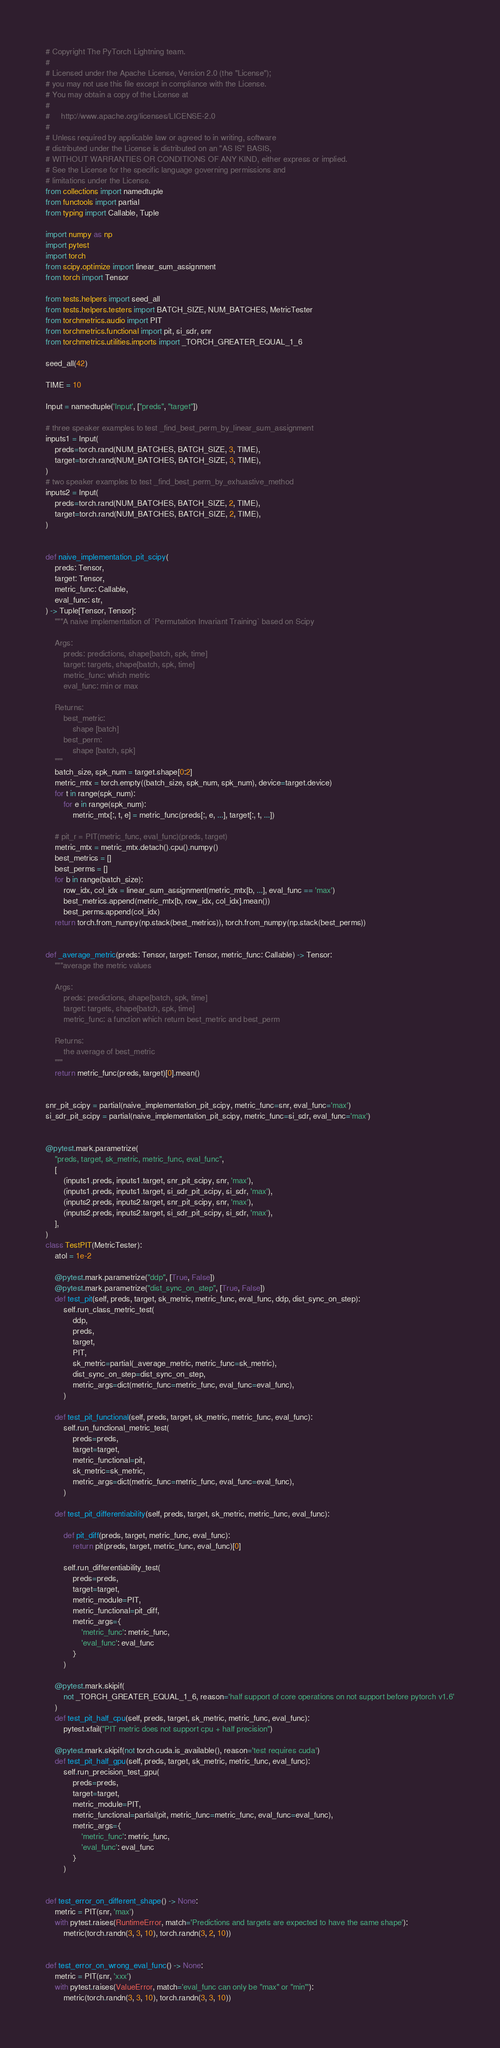<code> <loc_0><loc_0><loc_500><loc_500><_Python_># Copyright The PyTorch Lightning team.
#
# Licensed under the Apache License, Version 2.0 (the "License");
# you may not use this file except in compliance with the License.
# You may obtain a copy of the License at
#
#     http://www.apache.org/licenses/LICENSE-2.0
#
# Unless required by applicable law or agreed to in writing, software
# distributed under the License is distributed on an "AS IS" BASIS,
# WITHOUT WARRANTIES OR CONDITIONS OF ANY KIND, either express or implied.
# See the License for the specific language governing permissions and
# limitations under the License.
from collections import namedtuple
from functools import partial
from typing import Callable, Tuple

import numpy as np
import pytest
import torch
from scipy.optimize import linear_sum_assignment
from torch import Tensor

from tests.helpers import seed_all
from tests.helpers.testers import BATCH_SIZE, NUM_BATCHES, MetricTester
from torchmetrics.audio import PIT
from torchmetrics.functional import pit, si_sdr, snr
from torchmetrics.utilities.imports import _TORCH_GREATER_EQUAL_1_6

seed_all(42)

TIME = 10

Input = namedtuple('Input', ["preds", "target"])

# three speaker examples to test _find_best_perm_by_linear_sum_assignment
inputs1 = Input(
    preds=torch.rand(NUM_BATCHES, BATCH_SIZE, 3, TIME),
    target=torch.rand(NUM_BATCHES, BATCH_SIZE, 3, TIME),
)
# two speaker examples to test _find_best_perm_by_exhuastive_method
inputs2 = Input(
    preds=torch.rand(NUM_BATCHES, BATCH_SIZE, 2, TIME),
    target=torch.rand(NUM_BATCHES, BATCH_SIZE, 2, TIME),
)


def naive_implementation_pit_scipy(
    preds: Tensor,
    target: Tensor,
    metric_func: Callable,
    eval_func: str,
) -> Tuple[Tensor, Tensor]:
    """A naive implementation of `Permutation Invariant Training` based on Scipy

    Args:
        preds: predictions, shape[batch, spk, time]
        target: targets, shape[batch, spk, time]
        metric_func: which metric
        eval_func: min or max

    Returns:
        best_metric:
            shape [batch]
        best_perm:
            shape [batch, spk]
    """
    batch_size, spk_num = target.shape[0:2]
    metric_mtx = torch.empty((batch_size, spk_num, spk_num), device=target.device)
    for t in range(spk_num):
        for e in range(spk_num):
            metric_mtx[:, t, e] = metric_func(preds[:, e, ...], target[:, t, ...])

    # pit_r = PIT(metric_func, eval_func)(preds, target)
    metric_mtx = metric_mtx.detach().cpu().numpy()
    best_metrics = []
    best_perms = []
    for b in range(batch_size):
        row_idx, col_idx = linear_sum_assignment(metric_mtx[b, ...], eval_func == 'max')
        best_metrics.append(metric_mtx[b, row_idx, col_idx].mean())
        best_perms.append(col_idx)
    return torch.from_numpy(np.stack(best_metrics)), torch.from_numpy(np.stack(best_perms))


def _average_metric(preds: Tensor, target: Tensor, metric_func: Callable) -> Tensor:
    """average the metric values

    Args:
        preds: predictions, shape[batch, spk, time]
        target: targets, shape[batch, spk, time]
        metric_func: a function which return best_metric and best_perm

    Returns:
        the average of best_metric
    """
    return metric_func(preds, target)[0].mean()


snr_pit_scipy = partial(naive_implementation_pit_scipy, metric_func=snr, eval_func='max')
si_sdr_pit_scipy = partial(naive_implementation_pit_scipy, metric_func=si_sdr, eval_func='max')


@pytest.mark.parametrize(
    "preds, target, sk_metric, metric_func, eval_func",
    [
        (inputs1.preds, inputs1.target, snr_pit_scipy, snr, 'max'),
        (inputs1.preds, inputs1.target, si_sdr_pit_scipy, si_sdr, 'max'),
        (inputs2.preds, inputs2.target, snr_pit_scipy, snr, 'max'),
        (inputs2.preds, inputs2.target, si_sdr_pit_scipy, si_sdr, 'max'),
    ],
)
class TestPIT(MetricTester):
    atol = 1e-2

    @pytest.mark.parametrize("ddp", [True, False])
    @pytest.mark.parametrize("dist_sync_on_step", [True, False])
    def test_pit(self, preds, target, sk_metric, metric_func, eval_func, ddp, dist_sync_on_step):
        self.run_class_metric_test(
            ddp,
            preds,
            target,
            PIT,
            sk_metric=partial(_average_metric, metric_func=sk_metric),
            dist_sync_on_step=dist_sync_on_step,
            metric_args=dict(metric_func=metric_func, eval_func=eval_func),
        )

    def test_pit_functional(self, preds, target, sk_metric, metric_func, eval_func):
        self.run_functional_metric_test(
            preds=preds,
            target=target,
            metric_functional=pit,
            sk_metric=sk_metric,
            metric_args=dict(metric_func=metric_func, eval_func=eval_func),
        )

    def test_pit_differentiability(self, preds, target, sk_metric, metric_func, eval_func):

        def pit_diff(preds, target, metric_func, eval_func):
            return pit(preds, target, metric_func, eval_func)[0]

        self.run_differentiability_test(
            preds=preds,
            target=target,
            metric_module=PIT,
            metric_functional=pit_diff,
            metric_args={
                'metric_func': metric_func,
                'eval_func': eval_func
            }
        )

    @pytest.mark.skipif(
        not _TORCH_GREATER_EQUAL_1_6, reason='half support of core operations on not support before pytorch v1.6'
    )
    def test_pit_half_cpu(self, preds, target, sk_metric, metric_func, eval_func):
        pytest.xfail("PIT metric does not support cpu + half precision")

    @pytest.mark.skipif(not torch.cuda.is_available(), reason='test requires cuda')
    def test_pit_half_gpu(self, preds, target, sk_metric, metric_func, eval_func):
        self.run_precision_test_gpu(
            preds=preds,
            target=target,
            metric_module=PIT,
            metric_functional=partial(pit, metric_func=metric_func, eval_func=eval_func),
            metric_args={
                'metric_func': metric_func,
                'eval_func': eval_func
            }
        )


def test_error_on_different_shape() -> None:
    metric = PIT(snr, 'max')
    with pytest.raises(RuntimeError, match='Predictions and targets are expected to have the same shape'):
        metric(torch.randn(3, 3, 10), torch.randn(3, 2, 10))


def test_error_on_wrong_eval_func() -> None:
    metric = PIT(snr, 'xxx')
    with pytest.raises(ValueError, match='eval_func can only be "max" or "min"'):
        metric(torch.randn(3, 3, 10), torch.randn(3, 3, 10))

</code> 